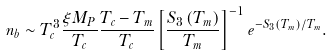<formula> <loc_0><loc_0><loc_500><loc_500>n _ { b } \sim T _ { c } ^ { 3 } \frac { \xi M _ { P } } { T _ { c } } \frac { T _ { c } - T _ { m } } { T _ { c } } \left [ \frac { S _ { 3 } \left ( T _ { m } \right ) } { T _ { m } } \right ] ^ { - 1 } e ^ { - S _ { 3 } \left ( T _ { m } \right ) / T _ { m } } .</formula> 